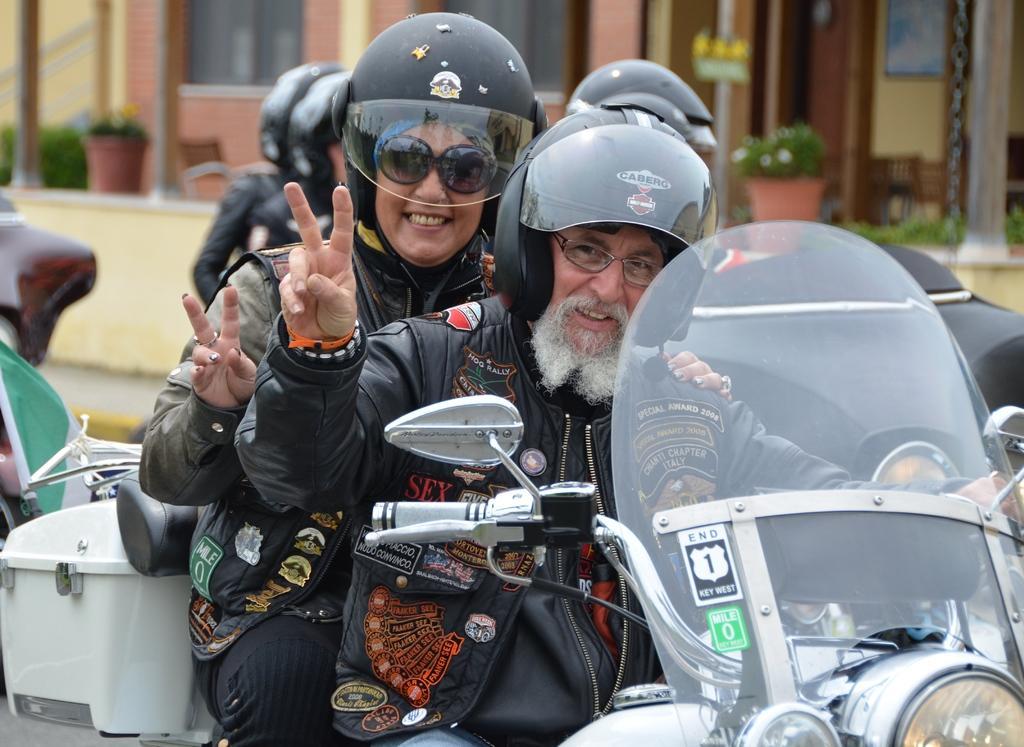In one or two sentences, can you explain what this image depicts? In this image I can see few people among them two people are riding bike by wearing a helmet and smiling. 